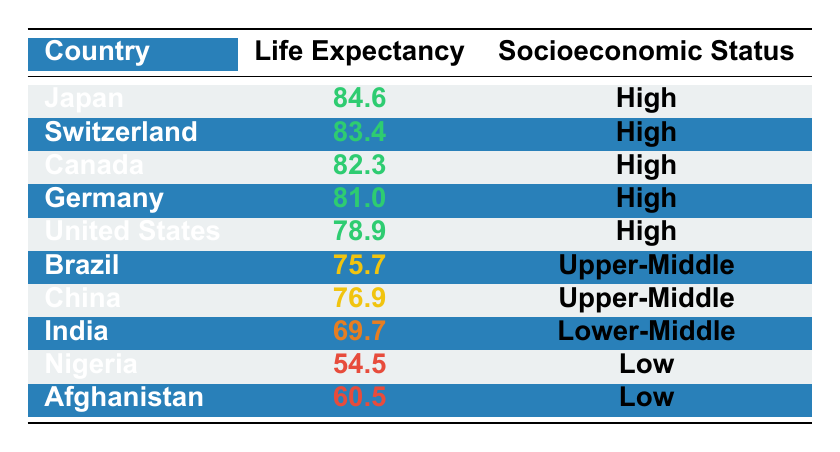What is the average life expectancy in Japan? According to the table, Japan has an average life expectancy of 84.6 years.
Answer: 84.6 Which country has the lowest life expectancy? The table shows that Nigeria has the lowest life expectancy at 54.5 years.
Answer: Nigeria What is the average life expectancy of Upper-Middle socioeconomic countries? The average life expectancy of Upper-Middle countries is (75.7 + 76.9) / 2 = 76.3 years.
Answer: 76.3 Is the life expectancy of Canada higher than that of Germany? Yes, Canada has an average life expectancy of 82.3 years, while Germany's is 81.0 years.
Answer: Yes What is the difference in life expectancy between the highest and lowest socioeconomic status groups? The highest life expectancy is in Japan at 84.6 years, and the lowest is in Nigeria at 54.5 years. The difference is 84.6 - 54.5 = 30.1 years.
Answer: 30.1 Is it true that all countries listed have an average life expectancy above 60 years? No, both Nigeria (54.5 years) and Afghanistan (60.5 years) are below 60 years or only at that threshold.
Answer: No How many countries listed have a life expectancy of 80 years or more? The countries with a life expectancy of 80 years or more are Japan, Switzerland, Canada, Germany, and the United States. There are 5 such countries in total.
Answer: 5 What is the median life expectancy of all countries listed? To find the median, we arrange the life expectancy values in ascending order: 54.5, 60.5, 69.7, 75.7, 76.9, 78.9, 81.0, 82.3, 83.4, 84.6. The median is (76.9 + 78.9) / 2 = 77.9 years since there are 10 values.
Answer: 77.9 How many countries fall into the High socioeconomic status group? The countries with High socioeconomic status are Japan, Switzerland, Canada, Germany, and the United States. There are 5 countries in total.
Answer: 5 